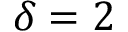Convert formula to latex. <formula><loc_0><loc_0><loc_500><loc_500>\delta = 2</formula> 